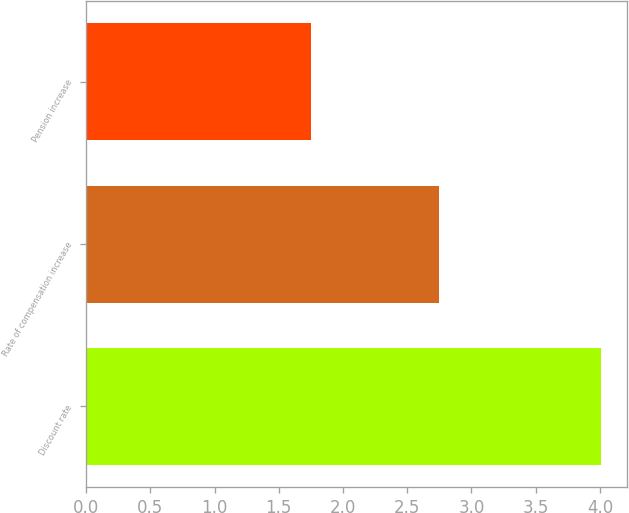Convert chart to OTSL. <chart><loc_0><loc_0><loc_500><loc_500><bar_chart><fcel>Discount rate<fcel>Rate of compensation increase<fcel>Pension increase<nl><fcel>4.01<fcel>2.75<fcel>1.75<nl></chart> 